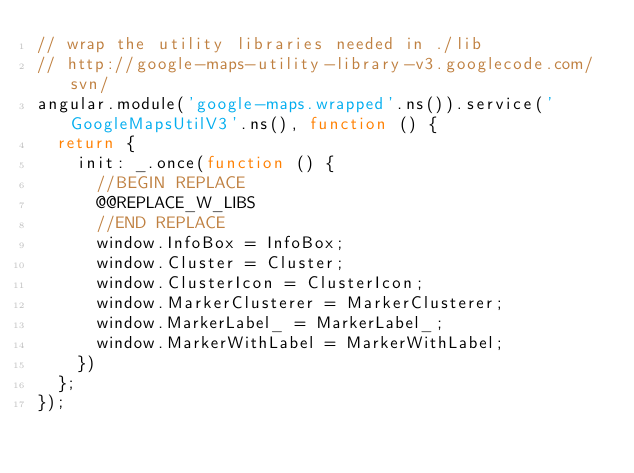Convert code to text. <code><loc_0><loc_0><loc_500><loc_500><_JavaScript_>// wrap the utility libraries needed in ./lib
// http://google-maps-utility-library-v3.googlecode.com/svn/
angular.module('google-maps.wrapped'.ns()).service('GoogleMapsUtilV3'.ns(), function () {
  return {
    init: _.once(function () {
      //BEGIN REPLACE
      @@REPLACE_W_LIBS
      //END REPLACE
      window.InfoBox = InfoBox;
      window.Cluster = Cluster;
      window.ClusterIcon = ClusterIcon;
      window.MarkerClusterer = MarkerClusterer;
      window.MarkerLabel_ = MarkerLabel_;
      window.MarkerWithLabel = MarkerWithLabel;
    })
  };
});</code> 